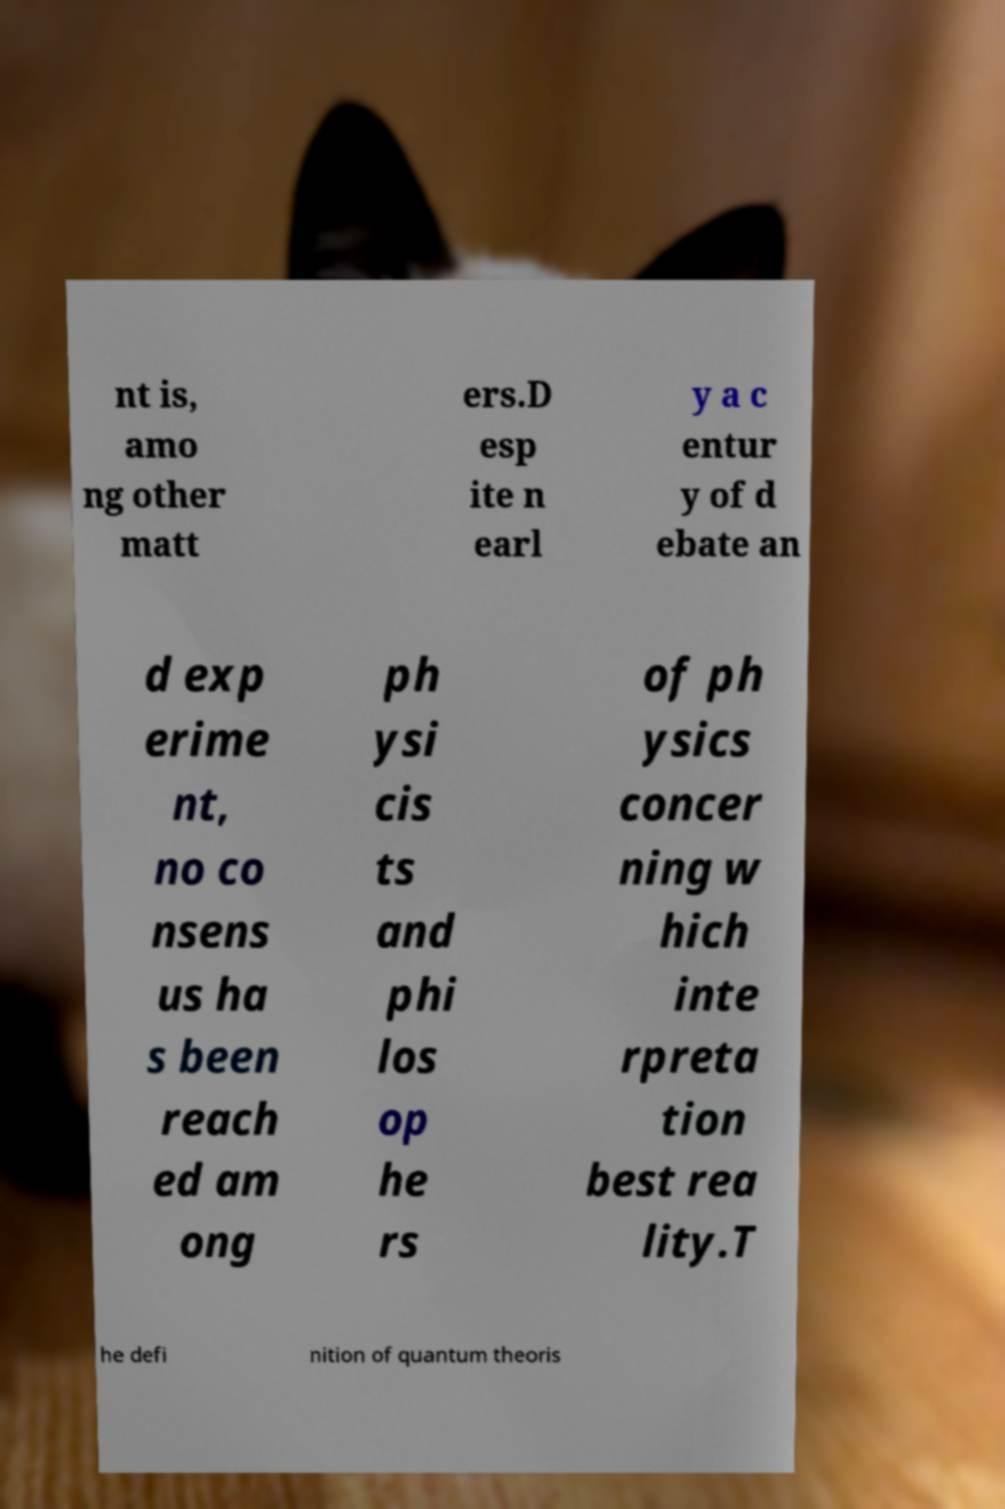Could you extract and type out the text from this image? nt is, amo ng other matt ers.D esp ite n earl y a c entur y of d ebate an d exp erime nt, no co nsens us ha s been reach ed am ong ph ysi cis ts and phi los op he rs of ph ysics concer ning w hich inte rpreta tion best rea lity.T he defi nition of quantum theoris 